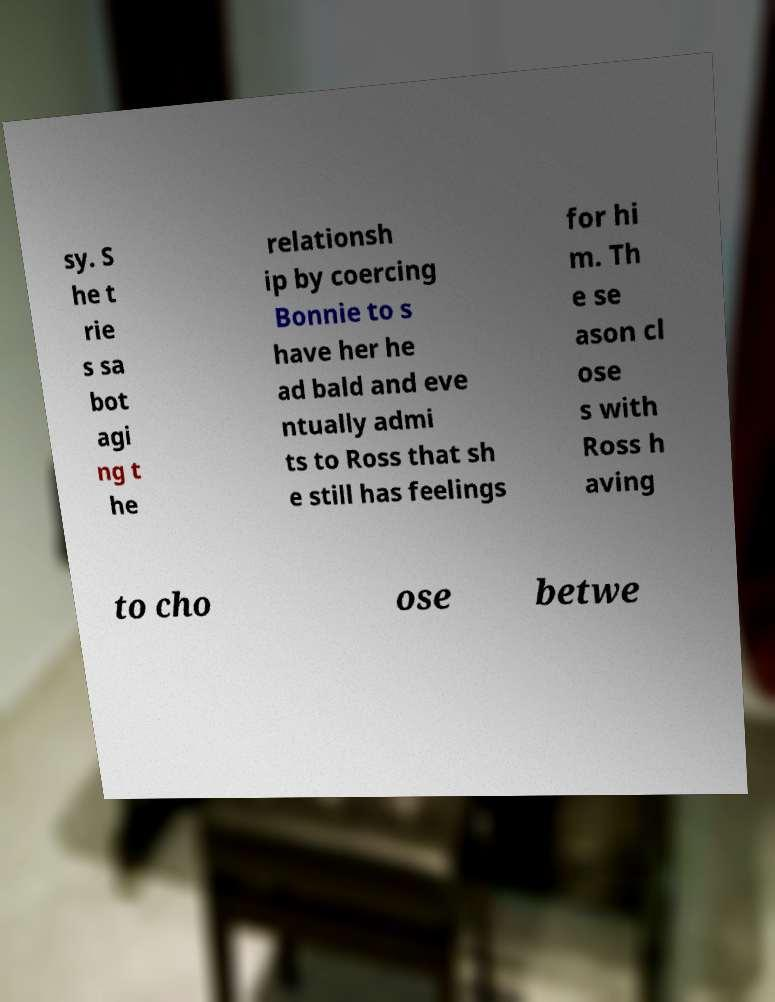Can you read and provide the text displayed in the image?This photo seems to have some interesting text. Can you extract and type it out for me? sy. S he t rie s sa bot agi ng t he relationsh ip by coercing Bonnie to s have her he ad bald and eve ntually admi ts to Ross that sh e still has feelings for hi m. Th e se ason cl ose s with Ross h aving to cho ose betwe 